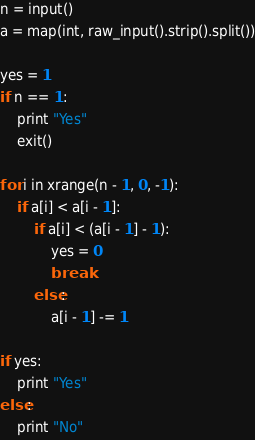Convert code to text. <code><loc_0><loc_0><loc_500><loc_500><_Python_>n = input()
a = map(int, raw_input().strip().split())

yes = 1
if n == 1:
    print "Yes"
    exit()

for i in xrange(n - 1, 0, -1):
    if a[i] < a[i - 1]:
        if a[i] < (a[i - 1] - 1):
            yes = 0
            break
        else:
            a[i - 1] -= 1

if yes:
    print "Yes"
else:
    print "No"</code> 